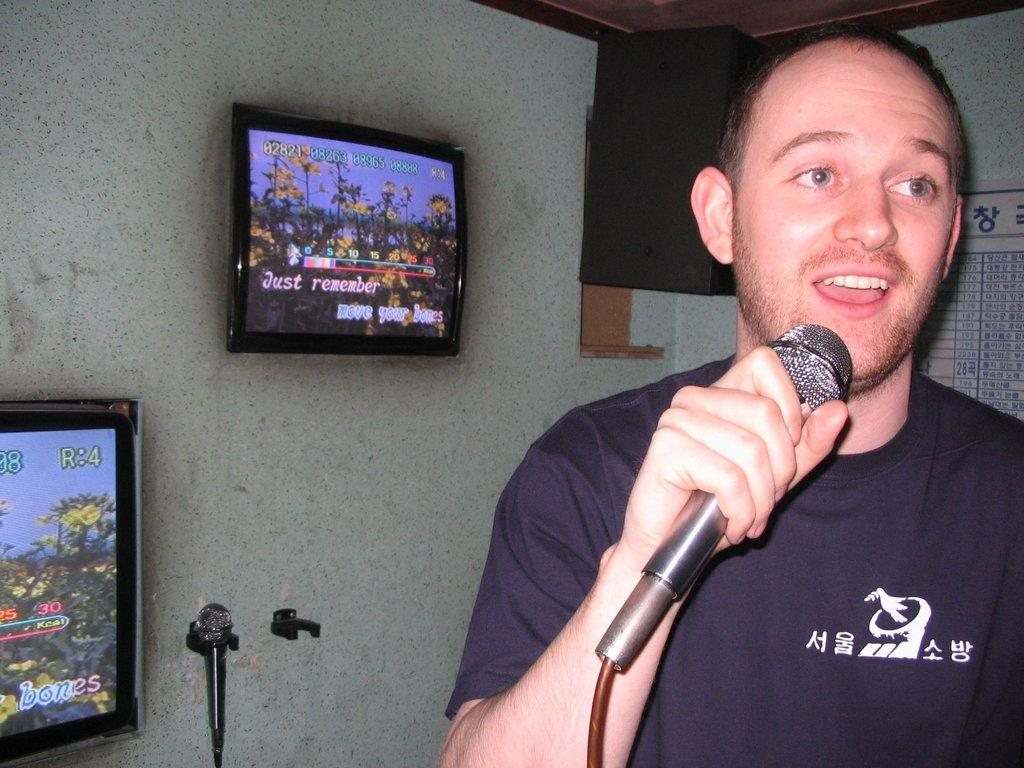What is the man in the image doing? The man is singing in the image. What is the man holding while singing? The man is holding a microphone. How many people are present in the image? There are two people in the image. What can be seen on the left side of the image? There is a wall on the left side of the image. What electronic devices are present in the image? There are two TV screens in the image. What type of tooth is visible in the image? There is no tooth visible in the image. What is the man doing with his head in the image? The man is singing, but there is no specific action with his head mentioned in the provided facts. 